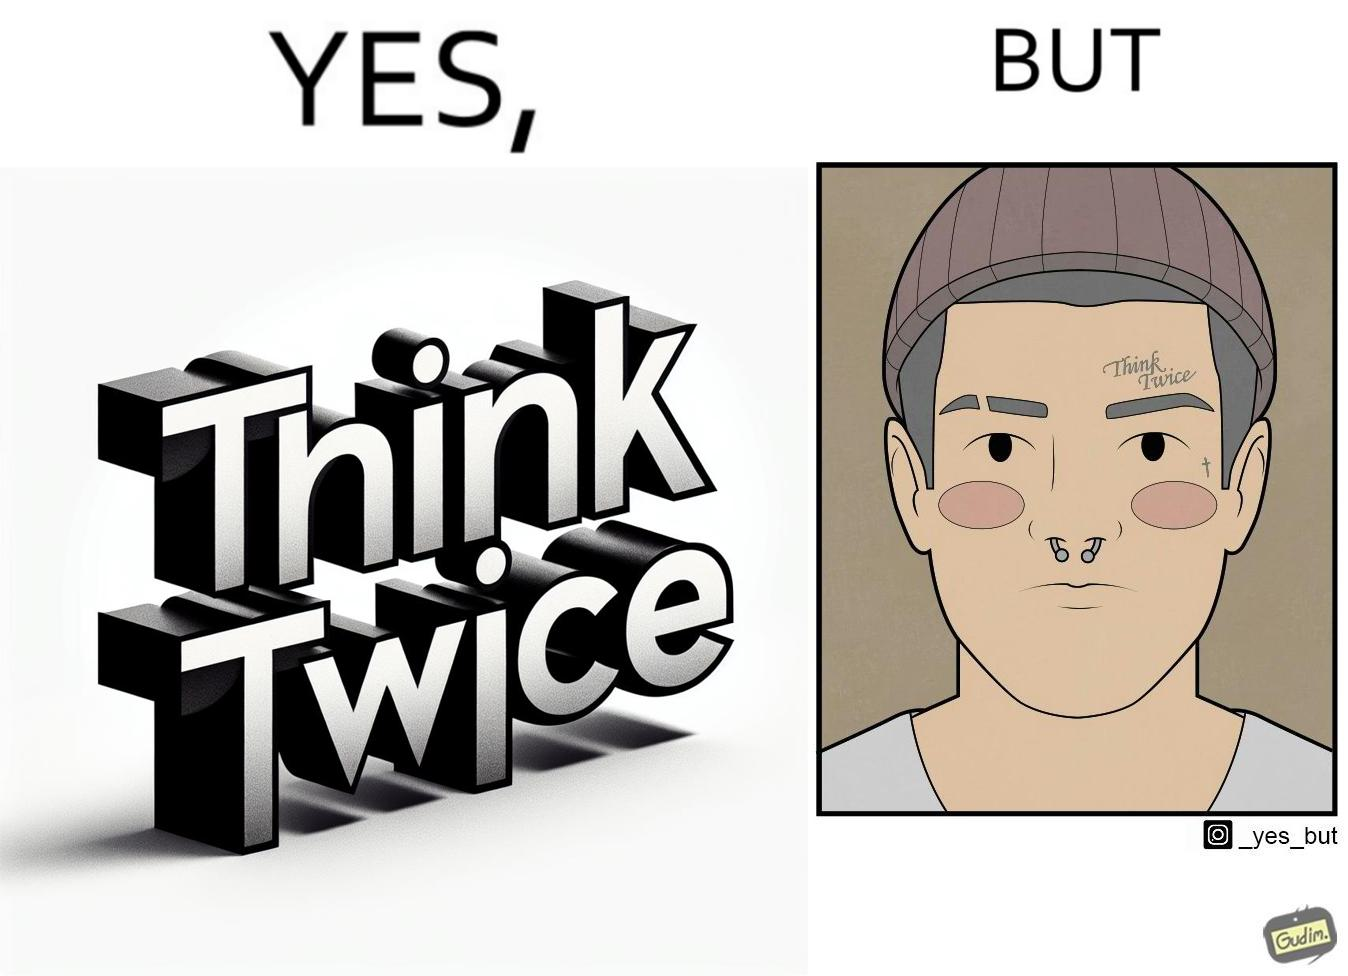Describe the contrast between the left and right parts of this image. In the left part of the image: The image shows a text in english saying "Think Twice". The font seems very fashionable. In the right part of the image: The image shows the face of a man with a tattoo on the left side of a forehead saying "Think Twice". The man is wearing a nose ring and has a cut on his left eyebrow. He also has a small tattoo of the cross a little below his left eye. 